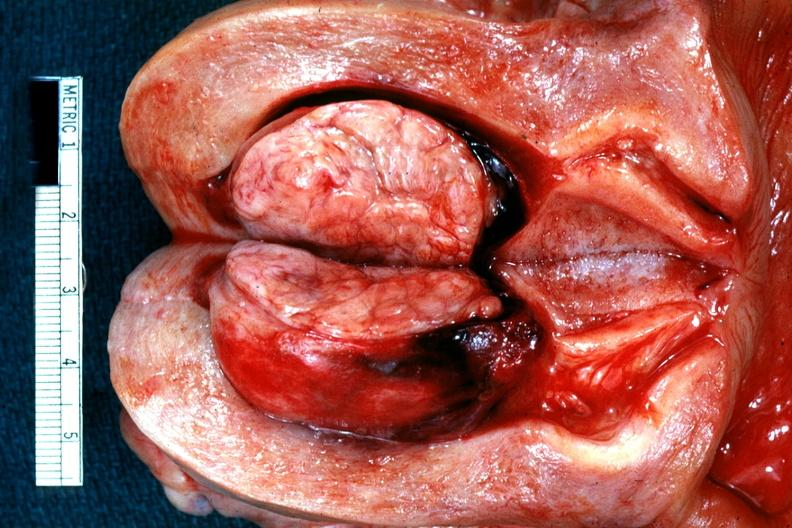where does this belong to?
Answer the question using a single word or phrase. Female reproductive system 